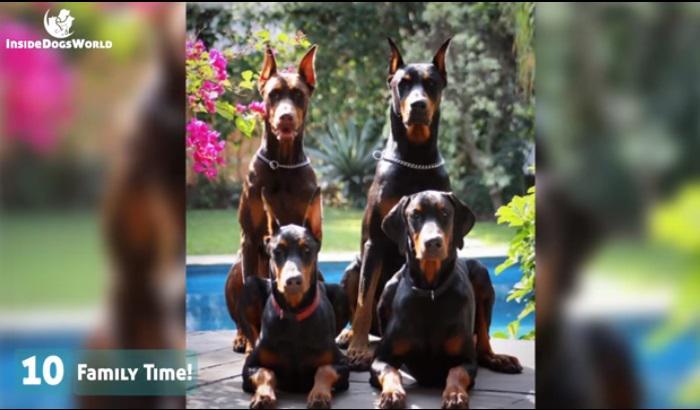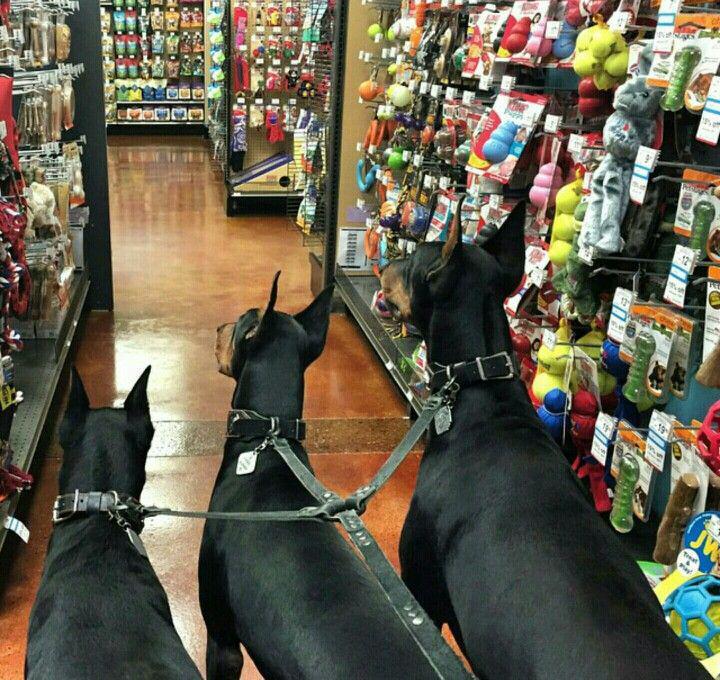The first image is the image on the left, the second image is the image on the right. Given the left and right images, does the statement "The right image contains exactly three doberman dogs with erect pointy ears wearing leashes and collars." hold true? Answer yes or no. Yes. 